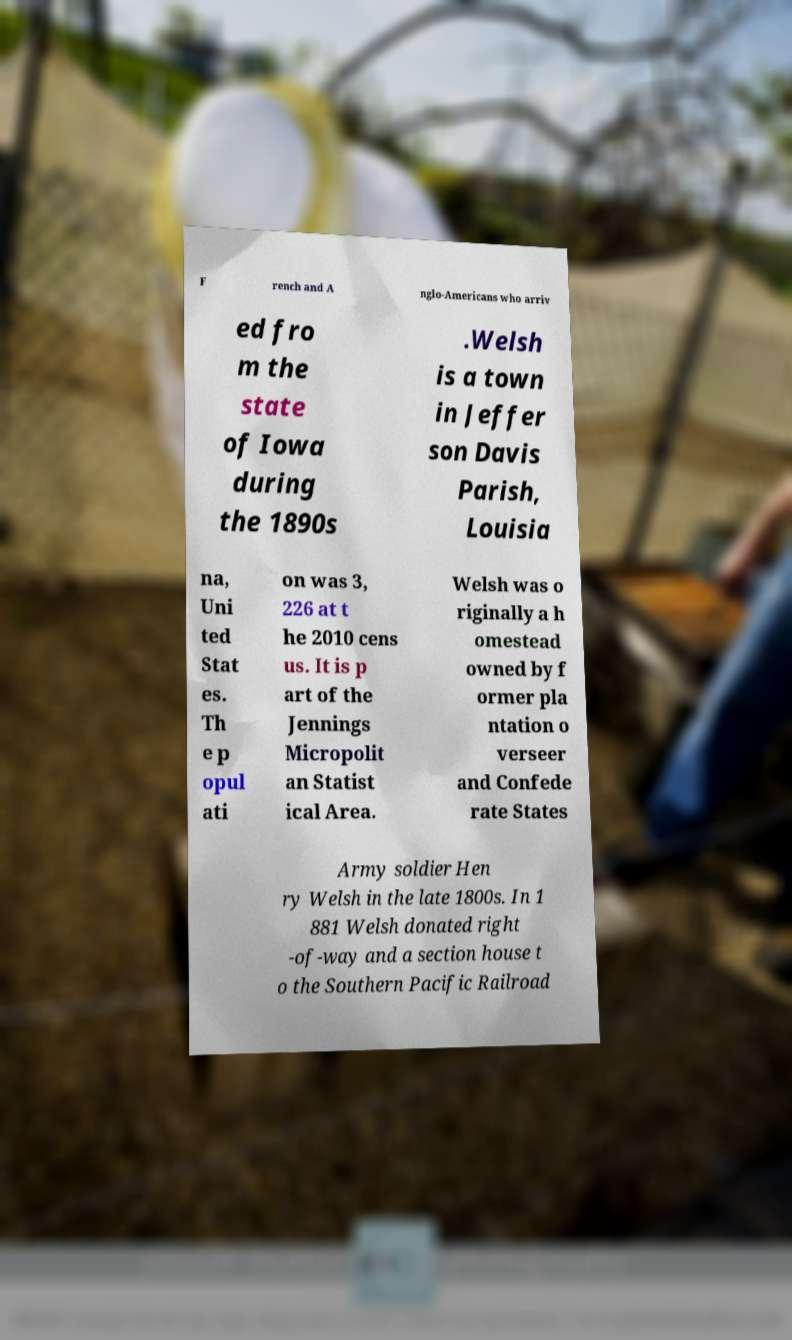I need the written content from this picture converted into text. Can you do that? F rench and A nglo-Americans who arriv ed fro m the state of Iowa during the 1890s .Welsh is a town in Jeffer son Davis Parish, Louisia na, Uni ted Stat es. Th e p opul ati on was 3, 226 at t he 2010 cens us. It is p art of the Jennings Micropolit an Statist ical Area. Welsh was o riginally a h omestead owned by f ormer pla ntation o verseer and Confede rate States Army soldier Hen ry Welsh in the late 1800s. In 1 881 Welsh donated right -of-way and a section house t o the Southern Pacific Railroad 